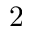<formula> <loc_0><loc_0><loc_500><loc_500>2</formula> 